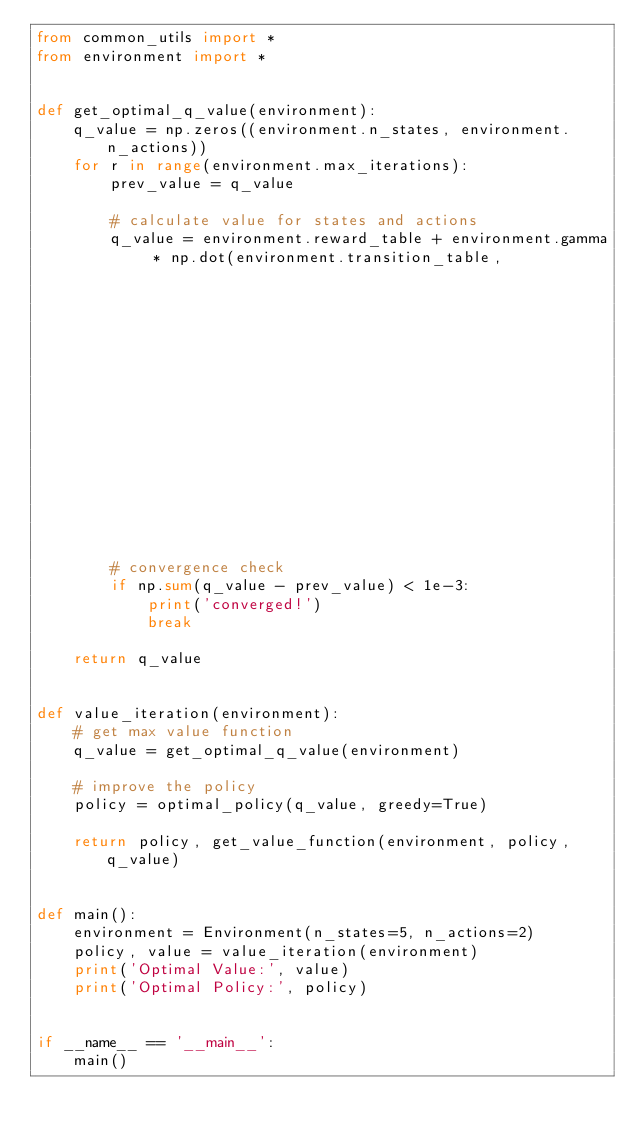<code> <loc_0><loc_0><loc_500><loc_500><_Python_>from common_utils import *
from environment import *


def get_optimal_q_value(environment):
    q_value = np.zeros((environment.n_states, environment.n_actions))
    for r in range(environment.max_iterations):
        prev_value = q_value

        # calculate value for states and actions
        q_value = environment.reward_table + environment.gamma * np.dot(environment.transition_table,
                                                                        get_value_function(environment, greedy_policy(q_value), q_value))

        # convergence check
        if np.sum(q_value - prev_value) < 1e-3:
            print('converged!')
            break

    return q_value


def value_iteration(environment):
    # get max value function
    q_value = get_optimal_q_value(environment)

    # improve the policy
    policy = optimal_policy(q_value, greedy=True)

    return policy, get_value_function(environment, policy, q_value)


def main():
    environment = Environment(n_states=5, n_actions=2)
    policy, value = value_iteration(environment)
    print('Optimal Value:', value)
    print('Optimal Policy:', policy)


if __name__ == '__main__':
    main()
</code> 